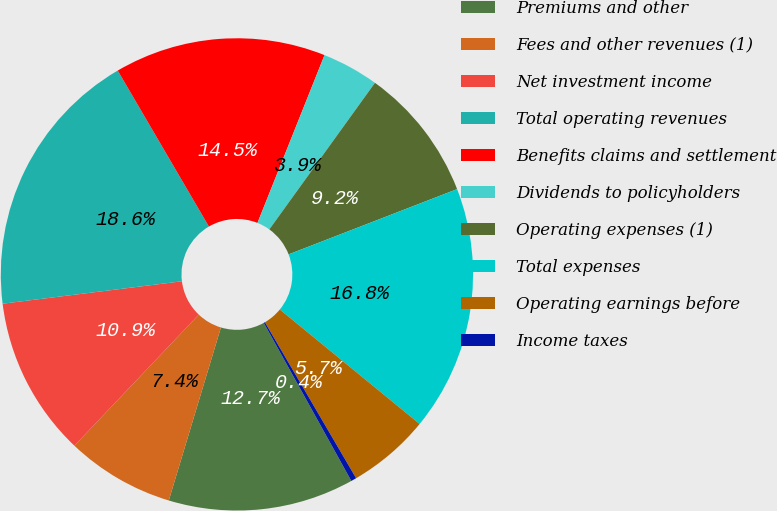<chart> <loc_0><loc_0><loc_500><loc_500><pie_chart><fcel>Premiums and other<fcel>Fees and other revenues (1)<fcel>Net investment income<fcel>Total operating revenues<fcel>Benefits claims and settlement<fcel>Dividends to policyholders<fcel>Operating expenses (1)<fcel>Total expenses<fcel>Operating earnings before<fcel>Income taxes<nl><fcel>12.71%<fcel>7.42%<fcel>10.94%<fcel>18.56%<fcel>14.47%<fcel>3.89%<fcel>9.18%<fcel>16.8%<fcel>5.66%<fcel>0.37%<nl></chart> 